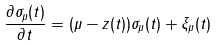Convert formula to latex. <formula><loc_0><loc_0><loc_500><loc_500>\frac { \partial \sigma _ { \mu } ( t ) } { \partial t } = ( \mu - z ( t ) ) \sigma _ { \mu } ( t ) + \xi _ { \mu } ( t )</formula> 